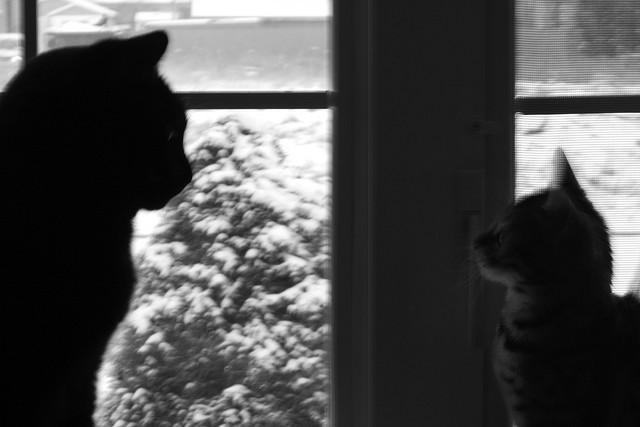How many baby kittens are there?
Keep it brief. 1. Are the cats looking out of the window?
Concise answer only. Yes. Is there screen on the window?
Quick response, please. Yes. Are the cats facing the same direction?
Answer briefly. No. What are the pointy things on its head?
Quick response, please. Ears. What's on the bushes in the background?
Concise answer only. Snow. 